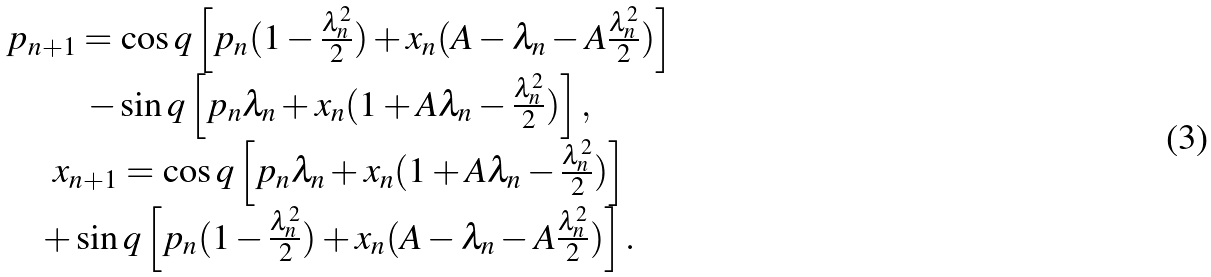<formula> <loc_0><loc_0><loc_500><loc_500>\begin{array} { c c } p _ { n + 1 } = \cos q \left [ p _ { n } ( 1 - \frac { \lambda _ { n } ^ { 2 } } { 2 } ) + x _ { n } ( A - \lambda _ { n } - A \frac { \lambda _ { n } ^ { 2 } } { 2 } ) \right ] \\ - \sin q \left [ p _ { n } \lambda _ { n } + x _ { n } ( 1 + A \lambda _ { n } - \frac { \lambda _ { n } ^ { 2 } } { 2 } ) \right ] , \\ x _ { n + 1 } = \cos q \left [ p _ { n } \lambda _ { n } + x _ { n } ( 1 + A \lambda _ { n } - \frac { \lambda _ { n } ^ { 2 } } { 2 } ) \right ] \\ + \sin q \left [ p _ { n } ( 1 - \frac { \lambda _ { n } ^ { 2 } } { 2 } ) + x _ { n } ( A - \lambda _ { n } - A \frac { \lambda _ { n } ^ { 2 } } { 2 } ) \right ] . \end{array}</formula> 